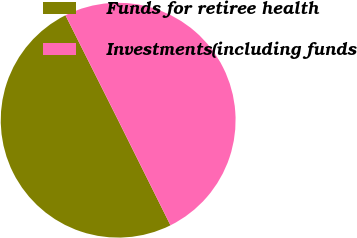Convert chart. <chart><loc_0><loc_0><loc_500><loc_500><pie_chart><fcel>Funds for retiree health<fcel>Investments(including funds<nl><fcel>49.94%<fcel>50.06%<nl></chart> 